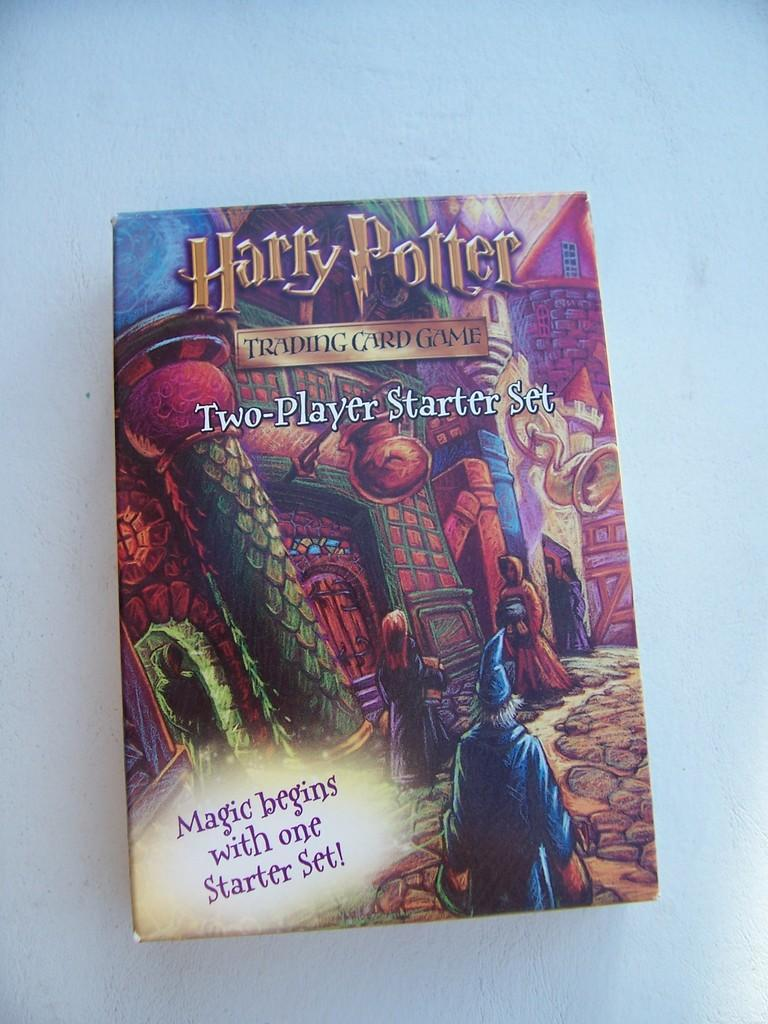<image>
Give a short and clear explanation of the subsequent image. a cover of a box for a harry potter trading card game 